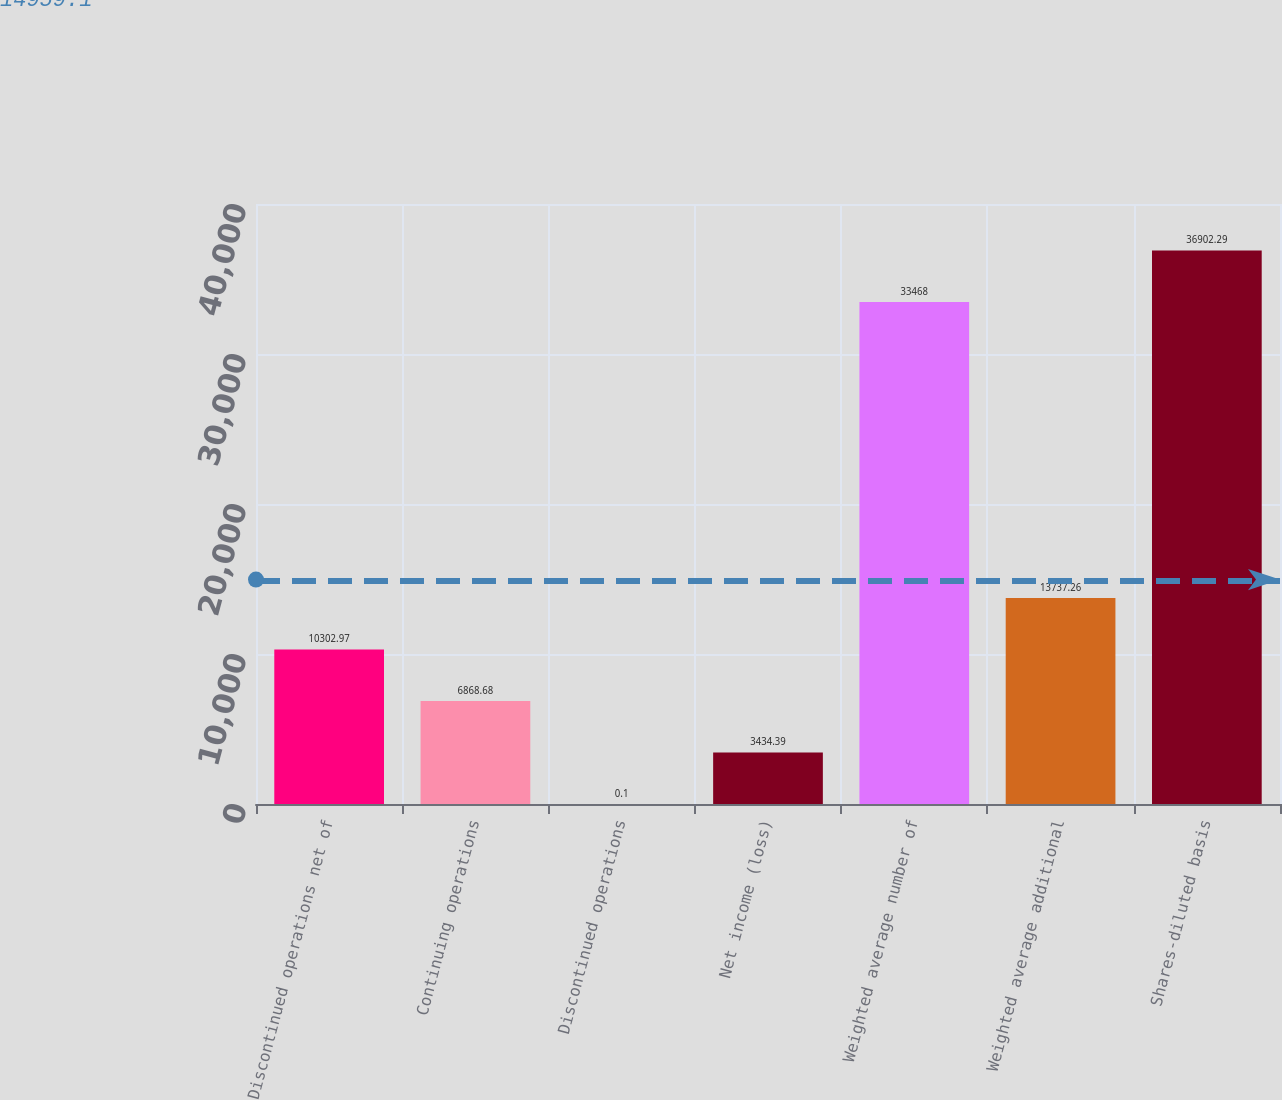Convert chart. <chart><loc_0><loc_0><loc_500><loc_500><bar_chart><fcel>Discontinued operations net of<fcel>Continuing operations<fcel>Discontinued operations<fcel>Net income (loss)<fcel>Weighted average number of<fcel>Weighted average additional<fcel>Shares-diluted basis<nl><fcel>10303<fcel>6868.68<fcel>0.1<fcel>3434.39<fcel>33468<fcel>13737.3<fcel>36902.3<nl></chart> 